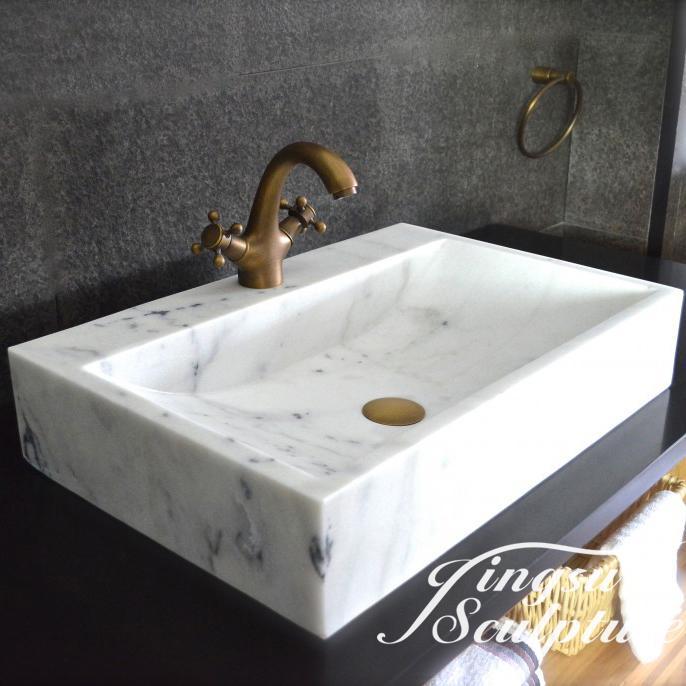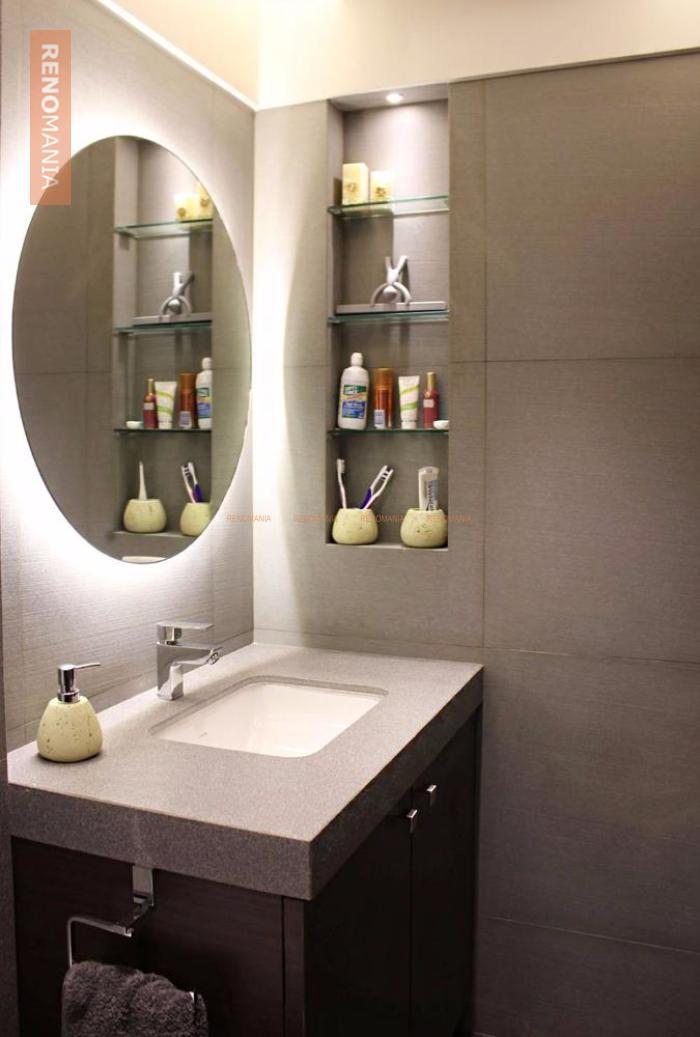The first image is the image on the left, the second image is the image on the right. Examine the images to the left and right. Is the description "The sink in the image on the right is shaped like a bowl." accurate? Answer yes or no. No. 